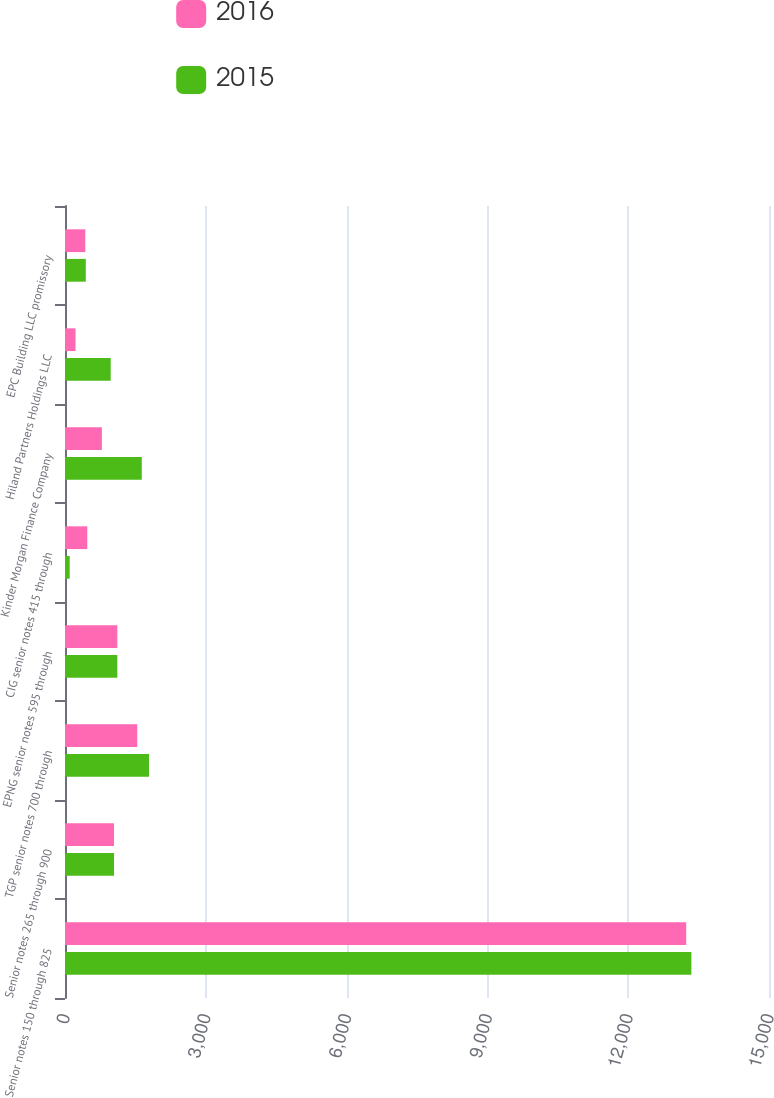<chart> <loc_0><loc_0><loc_500><loc_500><stacked_bar_chart><ecel><fcel>Senior notes 150 through 825<fcel>Senior notes 265 through 900<fcel>TGP senior notes 700 through<fcel>EPNG senior notes 595 through<fcel>CIG senior notes 415 through<fcel>Kinder Morgan Finance Company<fcel>Hiland Partners Holdings LLC<fcel>EPC Building LLC promissory<nl><fcel>2016<fcel>13236<fcel>1044.5<fcel>1540<fcel>1115<fcel>475<fcel>786<fcel>225<fcel>433<nl><fcel>2015<fcel>13346<fcel>1044.5<fcel>1790<fcel>1115<fcel>100<fcel>1636<fcel>974<fcel>443<nl></chart> 